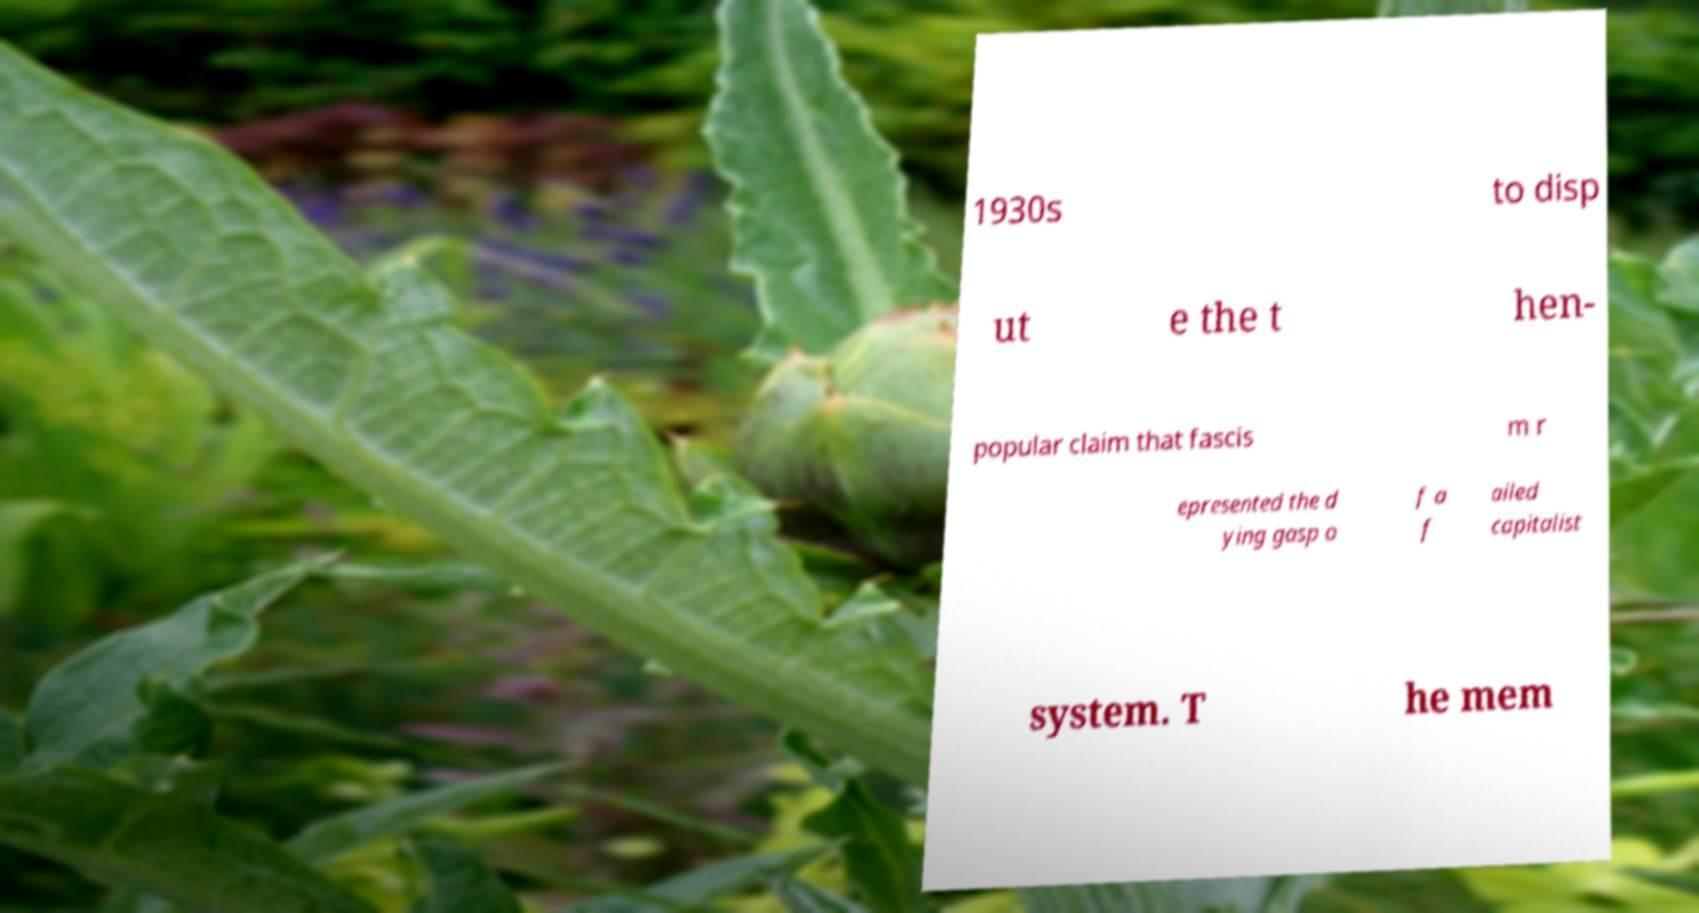Can you read and provide the text displayed in the image?This photo seems to have some interesting text. Can you extract and type it out for me? 1930s to disp ut e the t hen- popular claim that fascis m r epresented the d ying gasp o f a f ailed capitalist system. T he mem 